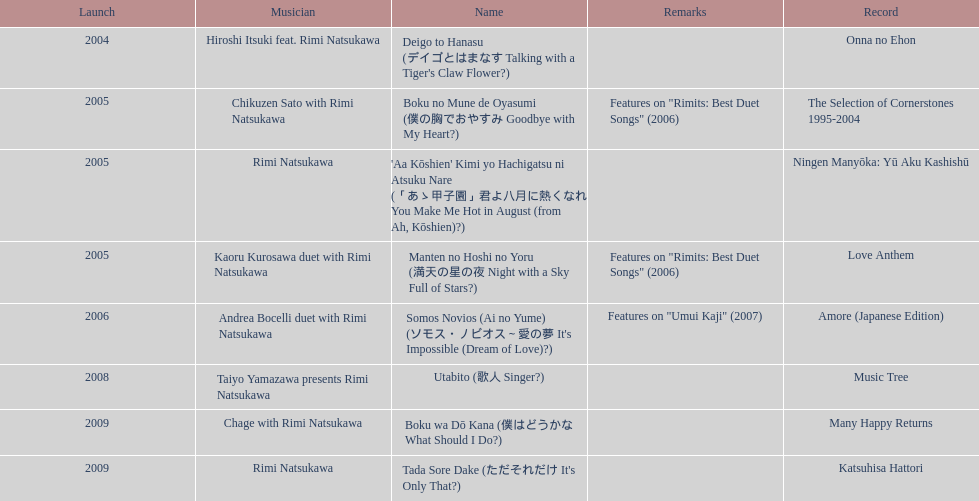What has been the last song this artist has made an other appearance on? Tada Sore Dake. 